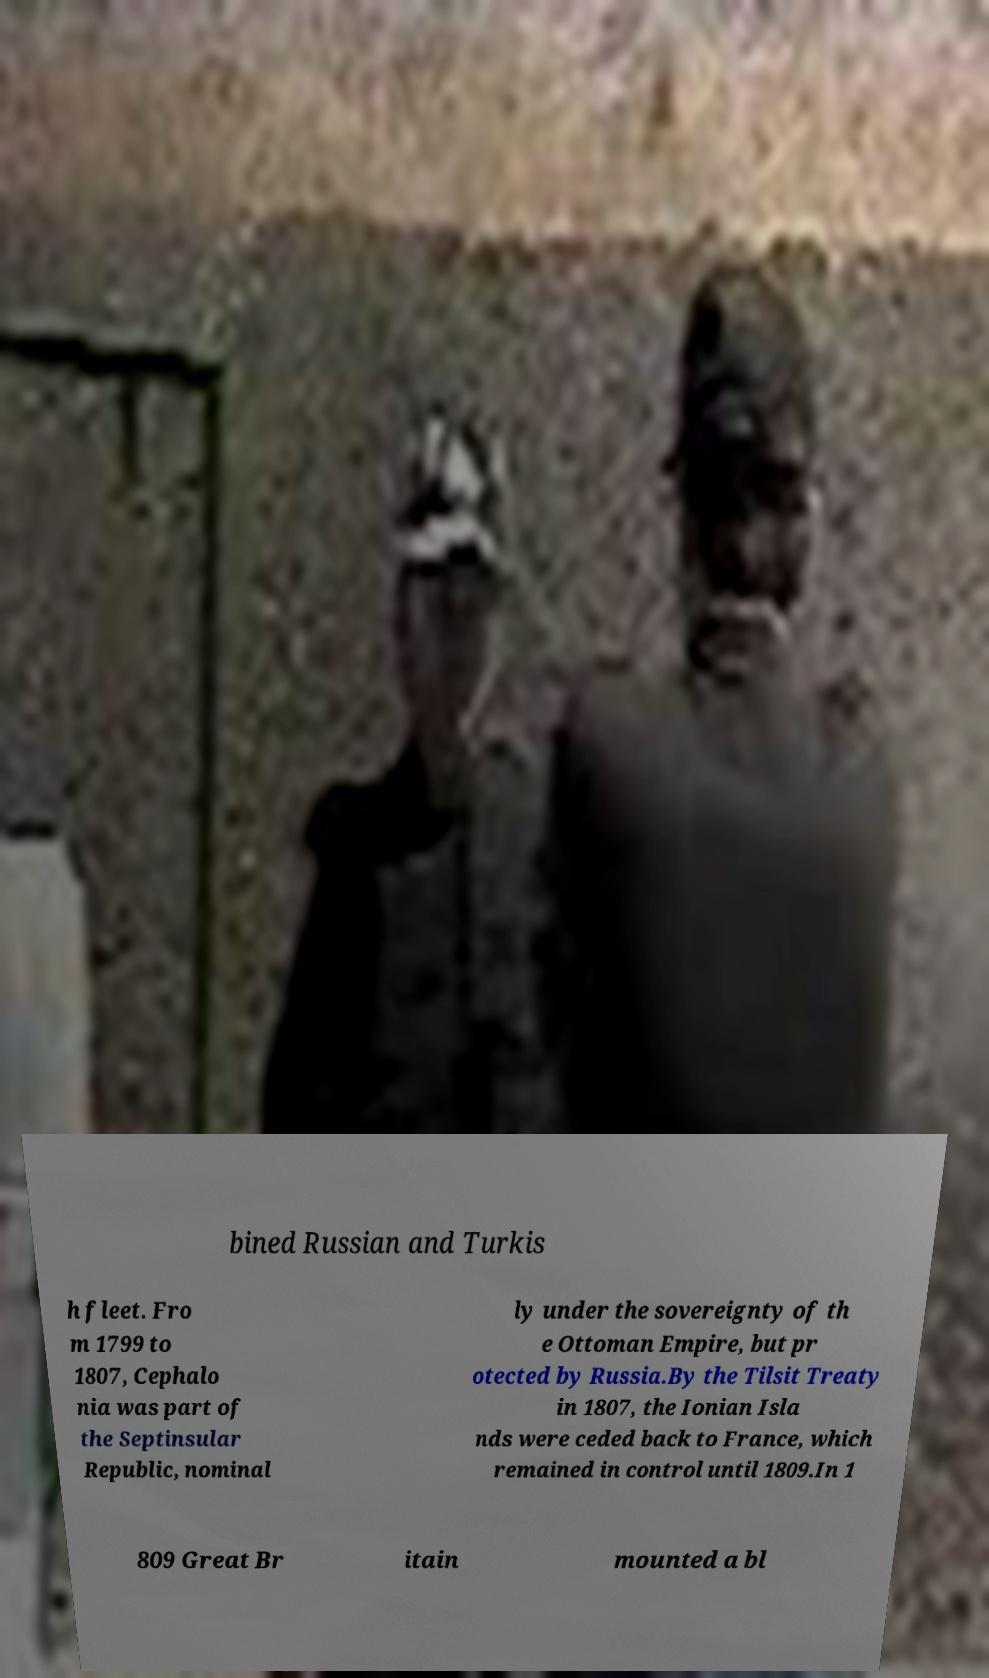Could you extract and type out the text from this image? bined Russian and Turkis h fleet. Fro m 1799 to 1807, Cephalo nia was part of the Septinsular Republic, nominal ly under the sovereignty of th e Ottoman Empire, but pr otected by Russia.By the Tilsit Treaty in 1807, the Ionian Isla nds were ceded back to France, which remained in control until 1809.In 1 809 Great Br itain mounted a bl 